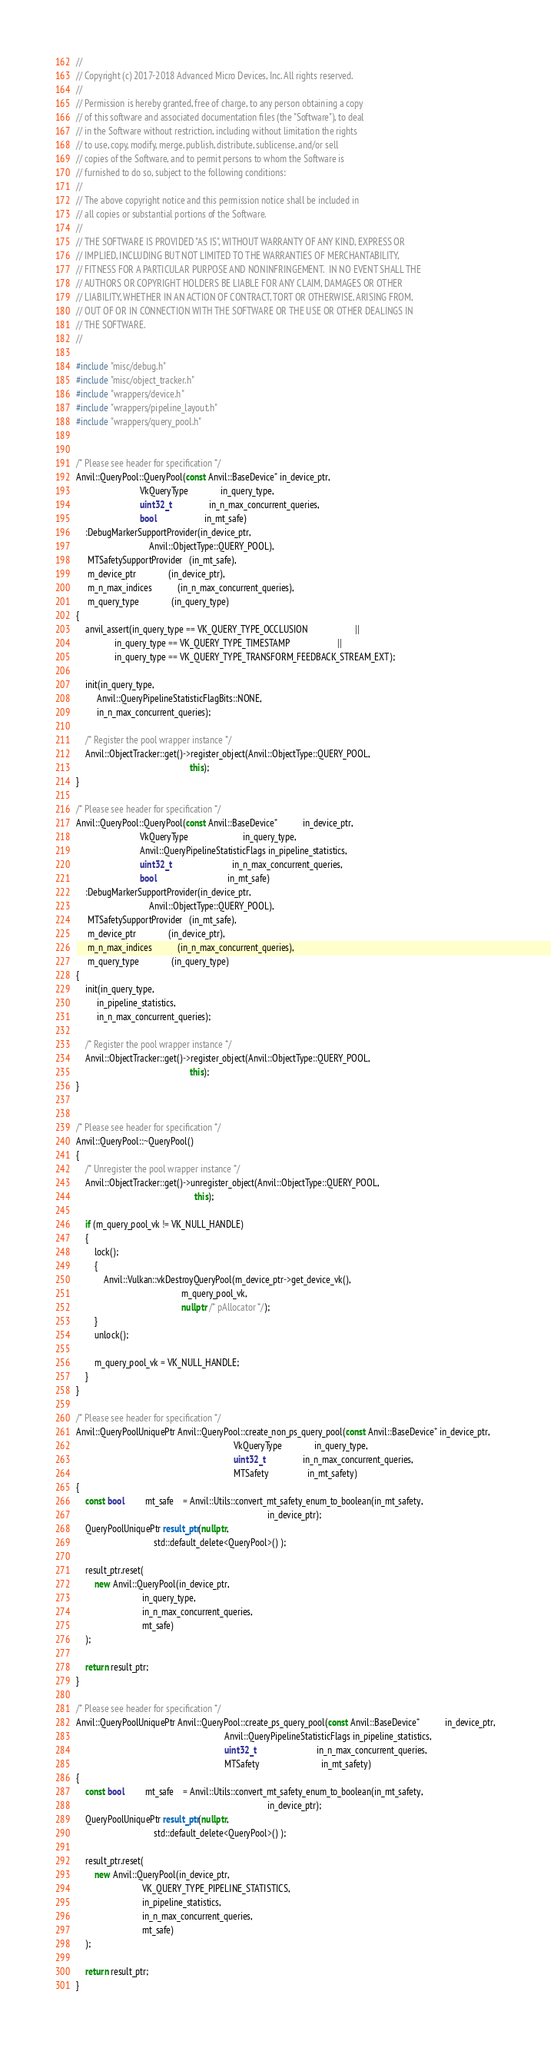<code> <loc_0><loc_0><loc_500><loc_500><_C++_>//
// Copyright (c) 2017-2018 Advanced Micro Devices, Inc. All rights reserved.
//
// Permission is hereby granted, free of charge, to any person obtaining a copy
// of this software and associated documentation files (the "Software"), to deal
// in the Software without restriction, including without limitation the rights
// to use, copy, modify, merge, publish, distribute, sublicense, and/or sell
// copies of the Software, and to permit persons to whom the Software is
// furnished to do so, subject to the following conditions:
//
// The above copyright notice and this permission notice shall be included in
// all copies or substantial portions of the Software.
//
// THE SOFTWARE IS PROVIDED "AS IS", WITHOUT WARRANTY OF ANY KIND, EXPRESS OR
// IMPLIED, INCLUDING BUT NOT LIMITED TO THE WARRANTIES OF MERCHANTABILITY,
// FITNESS FOR A PARTICULAR PURPOSE AND NONINFRINGEMENT.  IN NO EVENT SHALL THE
// AUTHORS OR COPYRIGHT HOLDERS BE LIABLE FOR ANY CLAIM, DAMAGES OR OTHER
// LIABILITY, WHETHER IN AN ACTION OF CONTRACT, TORT OR OTHERWISE, ARISING FROM,
// OUT OF OR IN CONNECTION WITH THE SOFTWARE OR THE USE OR OTHER DEALINGS IN
// THE SOFTWARE.
//

#include "misc/debug.h"
#include "misc/object_tracker.h"
#include "wrappers/device.h"
#include "wrappers/pipeline_layout.h"
#include "wrappers/query_pool.h"


/* Please see header for specification */
Anvil::QueryPool::QueryPool(const Anvil::BaseDevice* in_device_ptr,
                            VkQueryType              in_query_type,
                            uint32_t                 in_n_max_concurrent_queries,
                            bool                     in_mt_safe)
    :DebugMarkerSupportProvider(in_device_ptr,
                                Anvil::ObjectType::QUERY_POOL),
     MTSafetySupportProvider   (in_mt_safe),
     m_device_ptr              (in_device_ptr),
     m_n_max_indices           (in_n_max_concurrent_queries),
     m_query_type              (in_query_type)
{
    anvil_assert(in_query_type == VK_QUERY_TYPE_OCCLUSION                     ||
                 in_query_type == VK_QUERY_TYPE_TIMESTAMP                     ||
                 in_query_type == VK_QUERY_TYPE_TRANSFORM_FEEDBACK_STREAM_EXT);

    init(in_query_type,
         Anvil::QueryPipelineStatisticFlagBits::NONE,
         in_n_max_concurrent_queries);

    /* Register the pool wrapper instance */
    Anvil::ObjectTracker::get()->register_object(Anvil::ObjectType::QUERY_POOL,
                                                  this);
}

/* Please see header for specification */
Anvil::QueryPool::QueryPool(const Anvil::BaseDevice*           in_device_ptr,
                            VkQueryType                        in_query_type,
                            Anvil::QueryPipelineStatisticFlags in_pipeline_statistics,
                            uint32_t                           in_n_max_concurrent_queries,
                            bool                               in_mt_safe)
    :DebugMarkerSupportProvider(in_device_ptr,
                                Anvil::ObjectType::QUERY_POOL),
     MTSafetySupportProvider   (in_mt_safe),
     m_device_ptr              (in_device_ptr),
     m_n_max_indices           (in_n_max_concurrent_queries),
     m_query_type              (in_query_type)
{
    init(in_query_type,
         in_pipeline_statistics,
         in_n_max_concurrent_queries);

    /* Register the pool wrapper instance */
    Anvil::ObjectTracker::get()->register_object(Anvil::ObjectType::QUERY_POOL,
                                                  this);
}


/* Please see header for specification */
Anvil::QueryPool::~QueryPool()
{
    /* Unregister the pool wrapper instance */
    Anvil::ObjectTracker::get()->unregister_object(Anvil::ObjectType::QUERY_POOL,
                                                    this);

    if (m_query_pool_vk != VK_NULL_HANDLE)
    {
        lock();
        {
            Anvil::Vulkan::vkDestroyQueryPool(m_device_ptr->get_device_vk(),
                                              m_query_pool_vk,
                                              nullptr /* pAllocator */);
        }
        unlock();

        m_query_pool_vk = VK_NULL_HANDLE;
    }
}

/* Please see header for specification */
Anvil::QueryPoolUniquePtr Anvil::QueryPool::create_non_ps_query_pool(const Anvil::BaseDevice* in_device_ptr,
                                                                     VkQueryType              in_query_type,
                                                                     uint32_t                 in_n_max_concurrent_queries,
                                                                     MTSafety                 in_mt_safety)
{
    const bool         mt_safe    = Anvil::Utils::convert_mt_safety_enum_to_boolean(in_mt_safety,
                                                                                    in_device_ptr);
    QueryPoolUniquePtr result_ptr(nullptr,
                                  std::default_delete<QueryPool>() );

    result_ptr.reset(
        new Anvil::QueryPool(in_device_ptr,
                             in_query_type,
                             in_n_max_concurrent_queries,
                             mt_safe)
    );

    return result_ptr;
}

/* Please see header for specification */
Anvil::QueryPoolUniquePtr Anvil::QueryPool::create_ps_query_pool(const Anvil::BaseDevice*           in_device_ptr,
                                                                 Anvil::QueryPipelineStatisticFlags in_pipeline_statistics,
                                                                 uint32_t                           in_n_max_concurrent_queries,
                                                                 MTSafety                           in_mt_safety)
{
    const bool         mt_safe    = Anvil::Utils::convert_mt_safety_enum_to_boolean(in_mt_safety,
                                                                                    in_device_ptr);
    QueryPoolUniquePtr result_ptr(nullptr,
                                  std::default_delete<QueryPool>() );

    result_ptr.reset(
        new Anvil::QueryPool(in_device_ptr,
                             VK_QUERY_TYPE_PIPELINE_STATISTICS,
                             in_pipeline_statistics,
                             in_n_max_concurrent_queries,
                             mt_safe)
    );

    return result_ptr;
}
</code> 